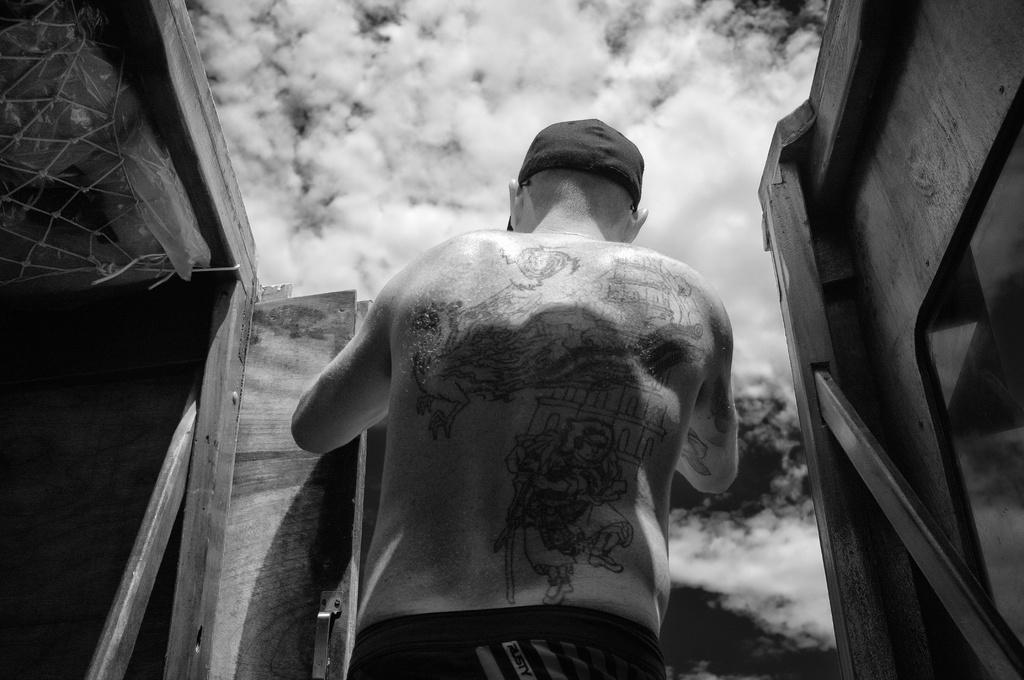What is the color scheme of the image? The image is black and white. Can you describe the main subject in the image? There is a person in the image. What can be seen on the left side of the side of the image? There are objects on the left side of the image. What can be seen on the right side of the image? There are objects on the right side of the image. What is visible in the background of the image? The sky is visible in the image, and clouds are present in the sky. What type of slope can be seen in the image? There is no slope present in the image. How is the person transporting the objects in the image? The image does not show the person transporting any objects. 